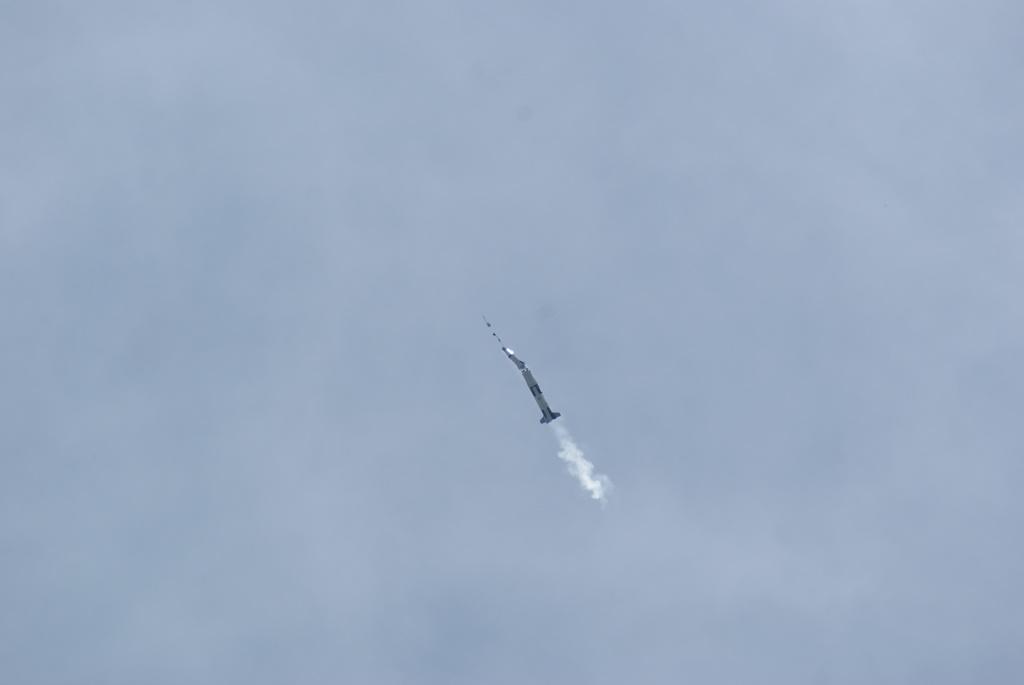Could you give a brief overview of what you see in this image? In the picture we can see a rocket in the sky leaving a smoke. 